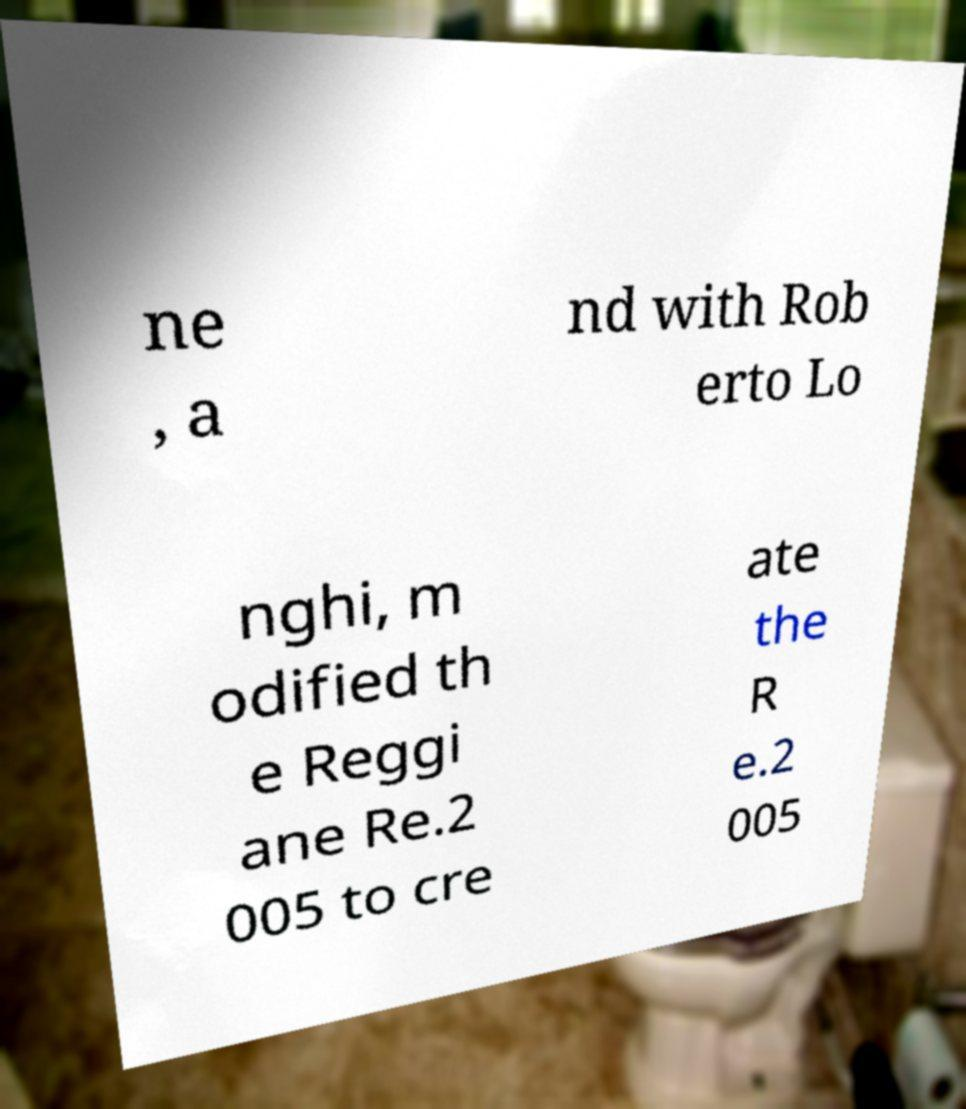Please identify and transcribe the text found in this image. ne , a nd with Rob erto Lo nghi, m odified th e Reggi ane Re.2 005 to cre ate the R e.2 005 